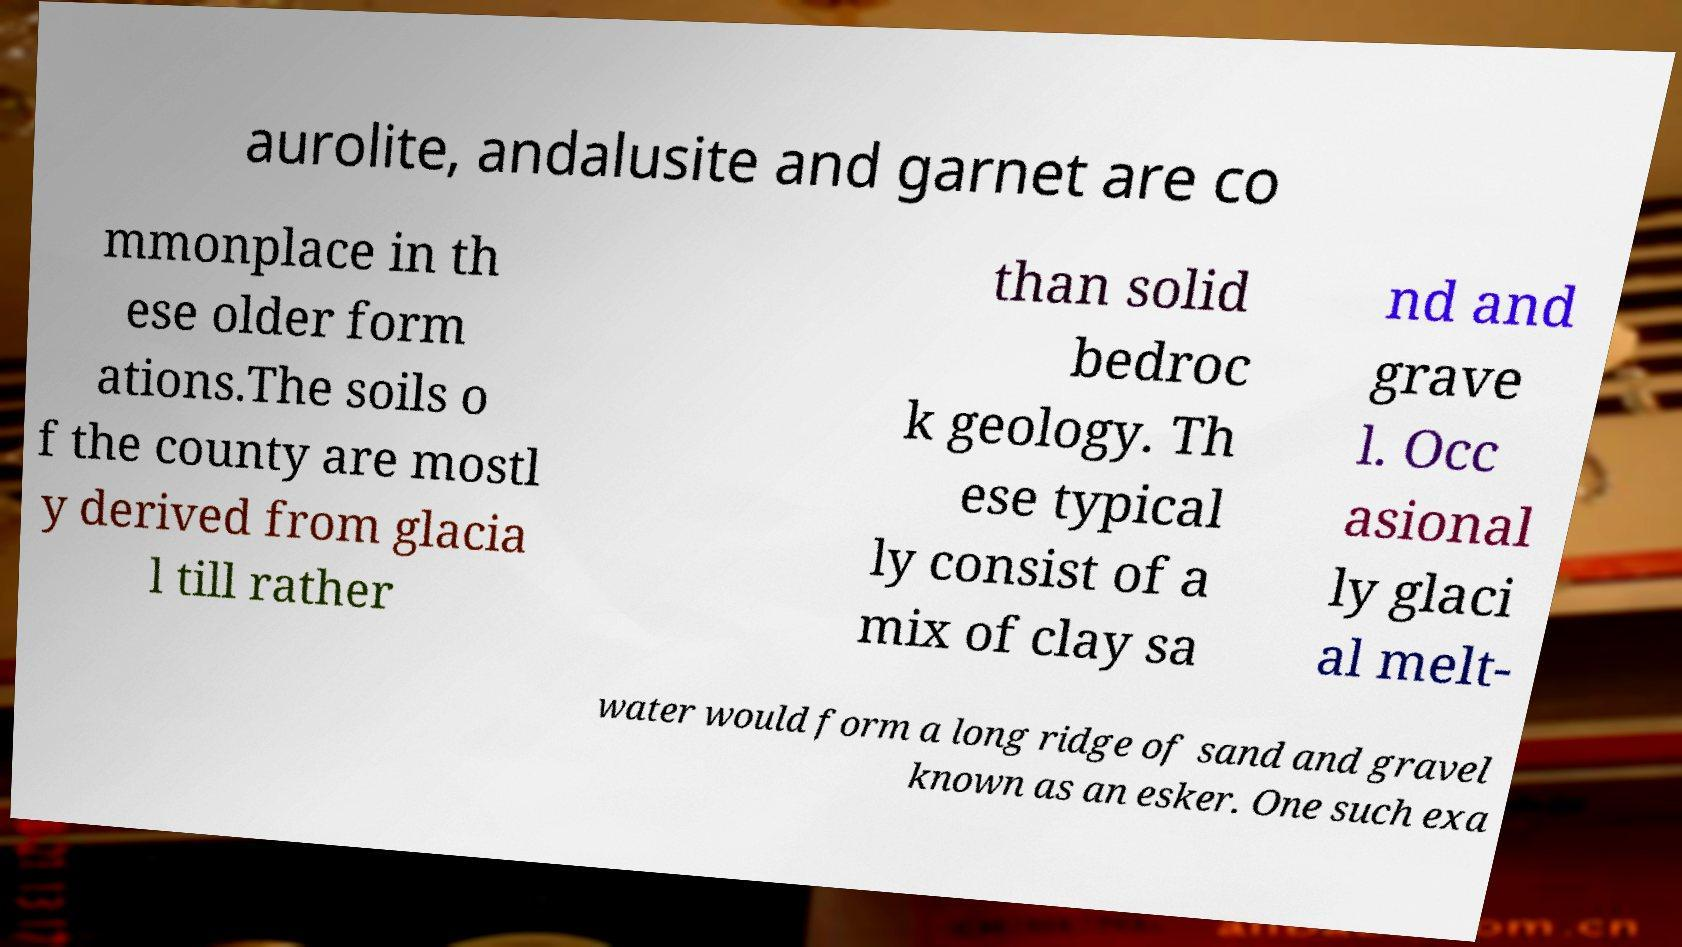Please read and relay the text visible in this image. What does it say? aurolite, andalusite and garnet are co mmonplace in th ese older form ations.The soils o f the county are mostl y derived from glacia l till rather than solid bedroc k geology. Th ese typical ly consist of a mix of clay sa nd and grave l. Occ asional ly glaci al melt- water would form a long ridge of sand and gravel known as an esker. One such exa 